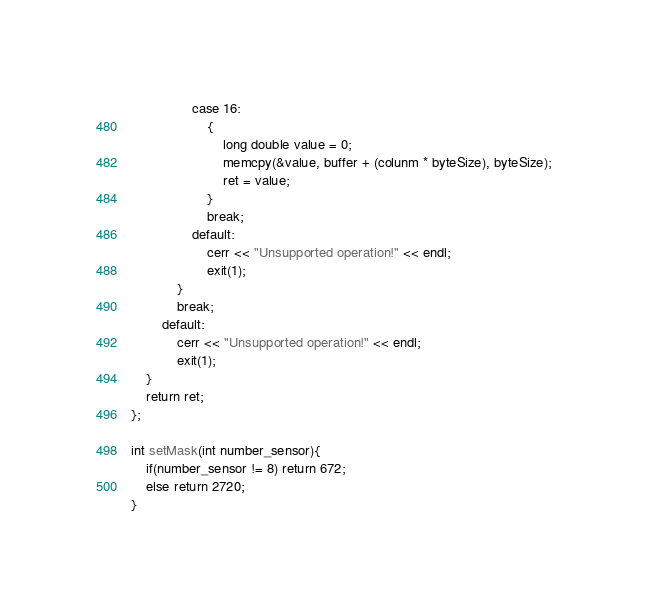Convert code to text. <code><loc_0><loc_0><loc_500><loc_500><_C++_>				case 16:
					{
						long double value = 0;
						memcpy(&value, buffer + (colunm * byteSize), byteSize);
						ret = value;
					}
					break;
				default:
					cerr << "Unsupported operation!" << endl;
					exit(1);
			}
			break;
		default:
			cerr << "Unsupported operation!" << endl;
			exit(1);
	}
	return ret;
};

int setMask(int number_sensor){
    if(number_sensor != 8) return 672;
    else return 2720;
}
</code> 